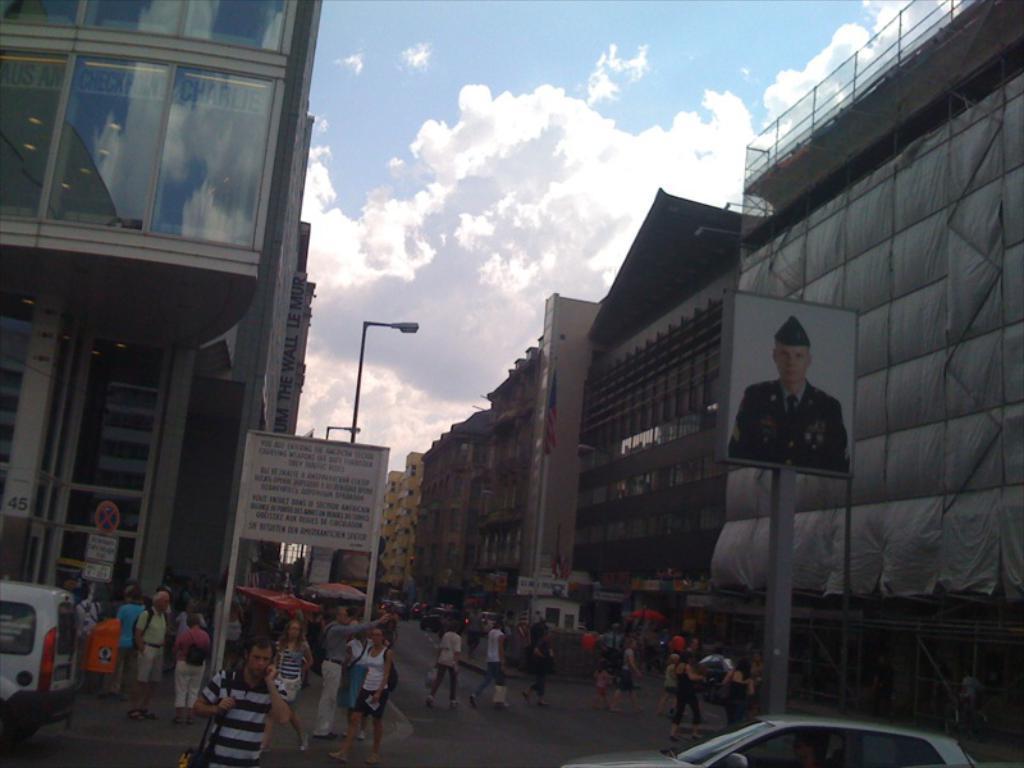Please provide a concise description of this image. There are some vehicles and some persons are standing as we can see at the bottom of this image. There is a board with text on the left side of this image, and there is a board with a picture of a person on the right side of this image, and there are some buildings in the background. There is a cloudy sky at the top of this image. 